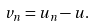Convert formula to latex. <formula><loc_0><loc_0><loc_500><loc_500>v _ { n } = u _ { n } - u .</formula> 